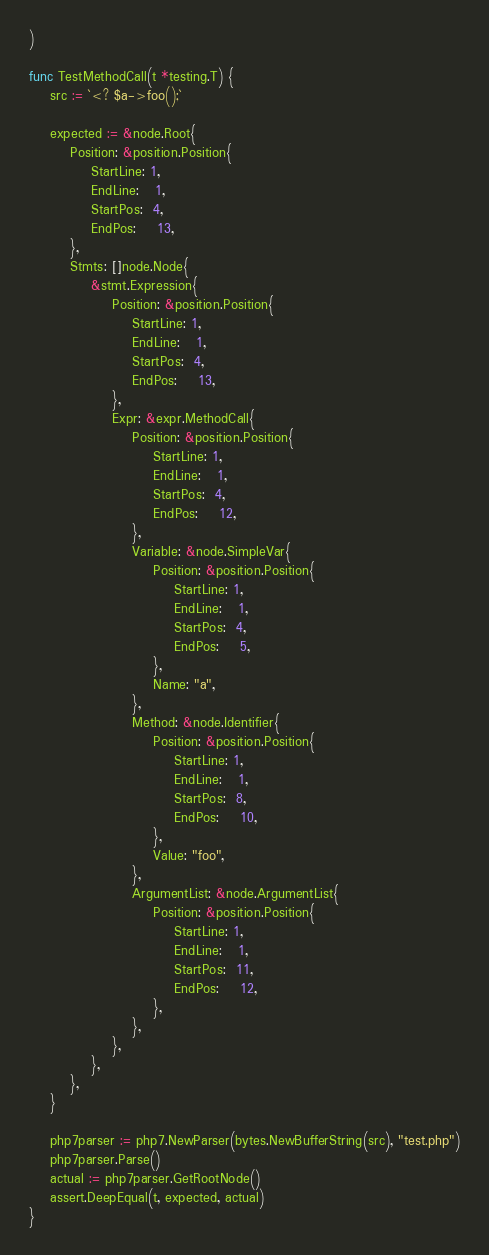Convert code to text. <code><loc_0><loc_0><loc_500><loc_500><_Go_>)

func TestMethodCall(t *testing.T) {
	src := `<? $a->foo();`

	expected := &node.Root{
		Position: &position.Position{
			StartLine: 1,
			EndLine:   1,
			StartPos:  4,
			EndPos:    13,
		},
		Stmts: []node.Node{
			&stmt.Expression{
				Position: &position.Position{
					StartLine: 1,
					EndLine:   1,
					StartPos:  4,
					EndPos:    13,
				},
				Expr: &expr.MethodCall{
					Position: &position.Position{
						StartLine: 1,
						EndLine:   1,
						StartPos:  4,
						EndPos:    12,
					},
					Variable: &node.SimpleVar{
						Position: &position.Position{
							StartLine: 1,
							EndLine:   1,
							StartPos:  4,
							EndPos:    5,
						},
						Name: "a",
					},
					Method: &node.Identifier{
						Position: &position.Position{
							StartLine: 1,
							EndLine:   1,
							StartPos:  8,
							EndPos:    10,
						},
						Value: "foo",
					},
					ArgumentList: &node.ArgumentList{
						Position: &position.Position{
							StartLine: 1,
							EndLine:   1,
							StartPos:  11,
							EndPos:    12,
						},
					},
				},
			},
		},
	}

	php7parser := php7.NewParser(bytes.NewBufferString(src), "test.php")
	php7parser.Parse()
	actual := php7parser.GetRootNode()
	assert.DeepEqual(t, expected, actual)
}
</code> 